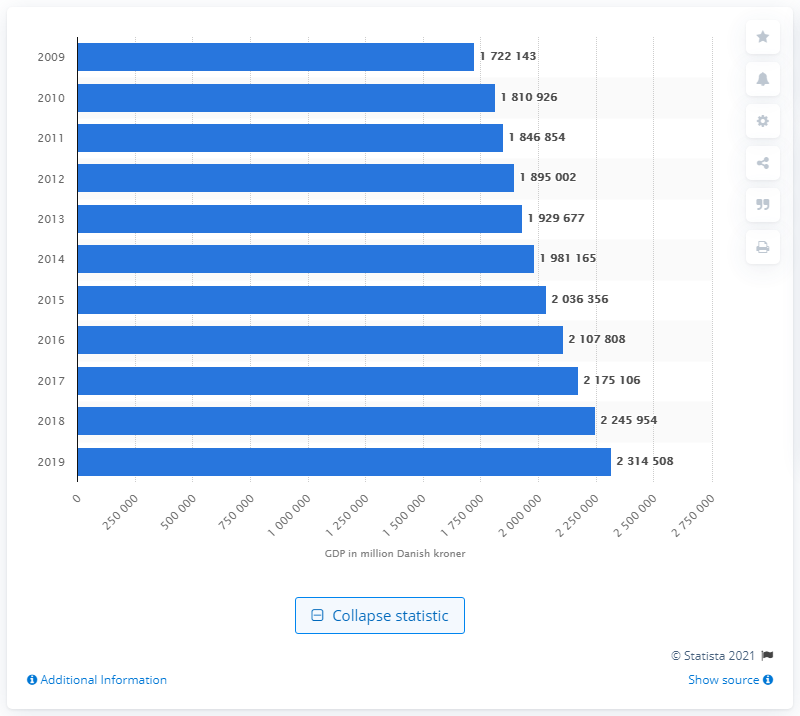List a handful of essential elements in this visual. In 2009, Denmark's Gross Domestic Product (GDP) increased on an annual basis. 